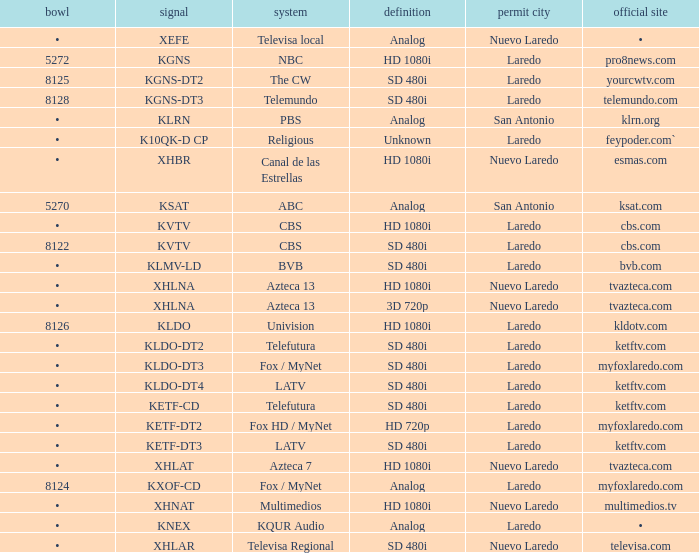Name the resolution with dish of 8126 HD 1080i. 